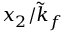<formula> <loc_0><loc_0><loc_500><loc_500>x _ { 2 } / \tilde { k } _ { f }</formula> 